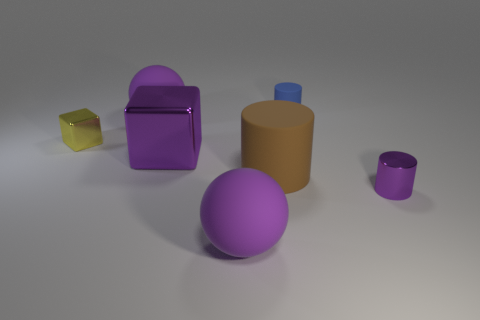Subtract all small cylinders. How many cylinders are left? 1 Subtract 1 cylinders. How many cylinders are left? 2 Add 1 small metallic balls. How many objects exist? 8 Subtract all gray cylinders. Subtract all yellow blocks. How many cylinders are left? 3 Subtract all cylinders. How many objects are left? 4 Subtract 1 brown cylinders. How many objects are left? 6 Subtract all brown cylinders. Subtract all tiny purple cylinders. How many objects are left? 5 Add 3 small yellow metallic cubes. How many small yellow metallic cubes are left? 4 Add 7 red cubes. How many red cubes exist? 7 